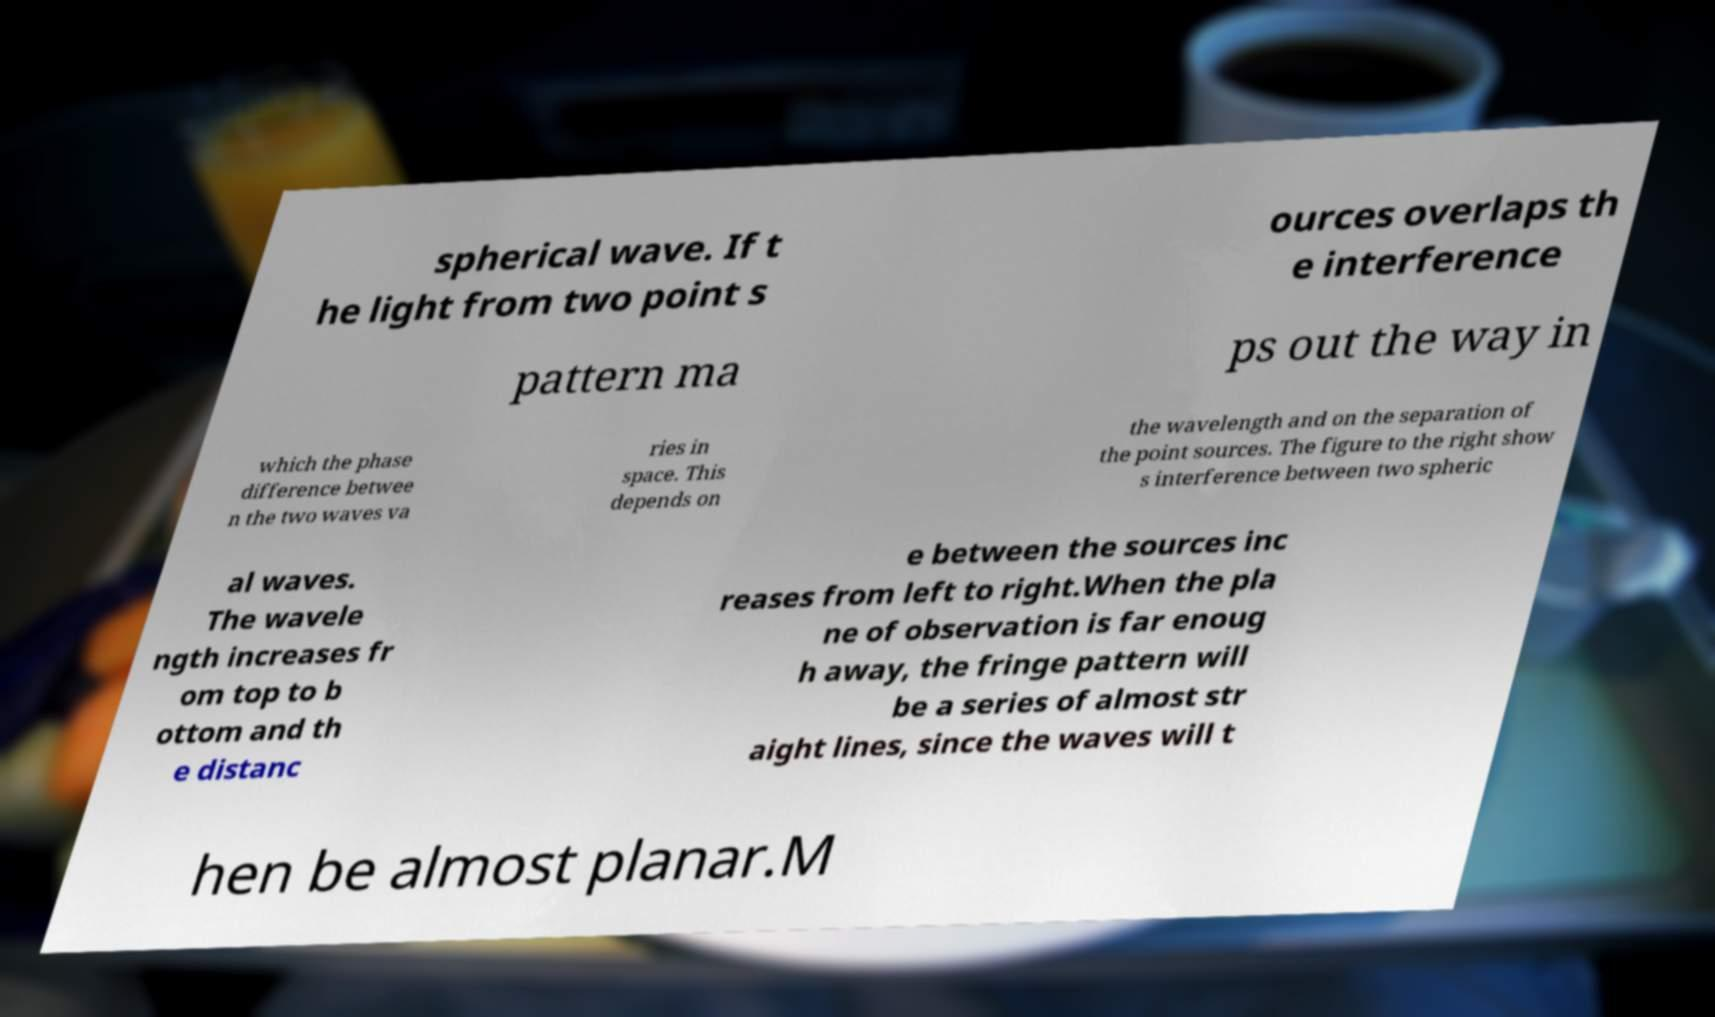Please identify and transcribe the text found in this image. spherical wave. If t he light from two point s ources overlaps th e interference pattern ma ps out the way in which the phase difference betwee n the two waves va ries in space. This depends on the wavelength and on the separation of the point sources. The figure to the right show s interference between two spheric al waves. The wavele ngth increases fr om top to b ottom and th e distanc e between the sources inc reases from left to right.When the pla ne of observation is far enoug h away, the fringe pattern will be a series of almost str aight lines, since the waves will t hen be almost planar.M 